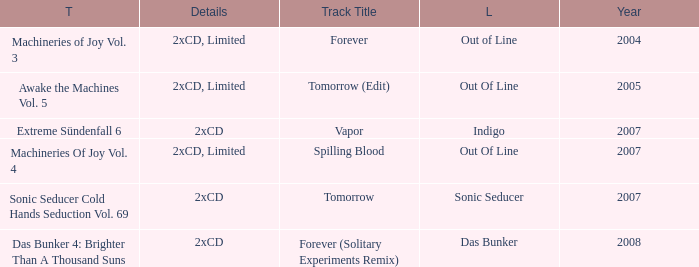Which track title has a year lesser thsn 2005? Forever. 